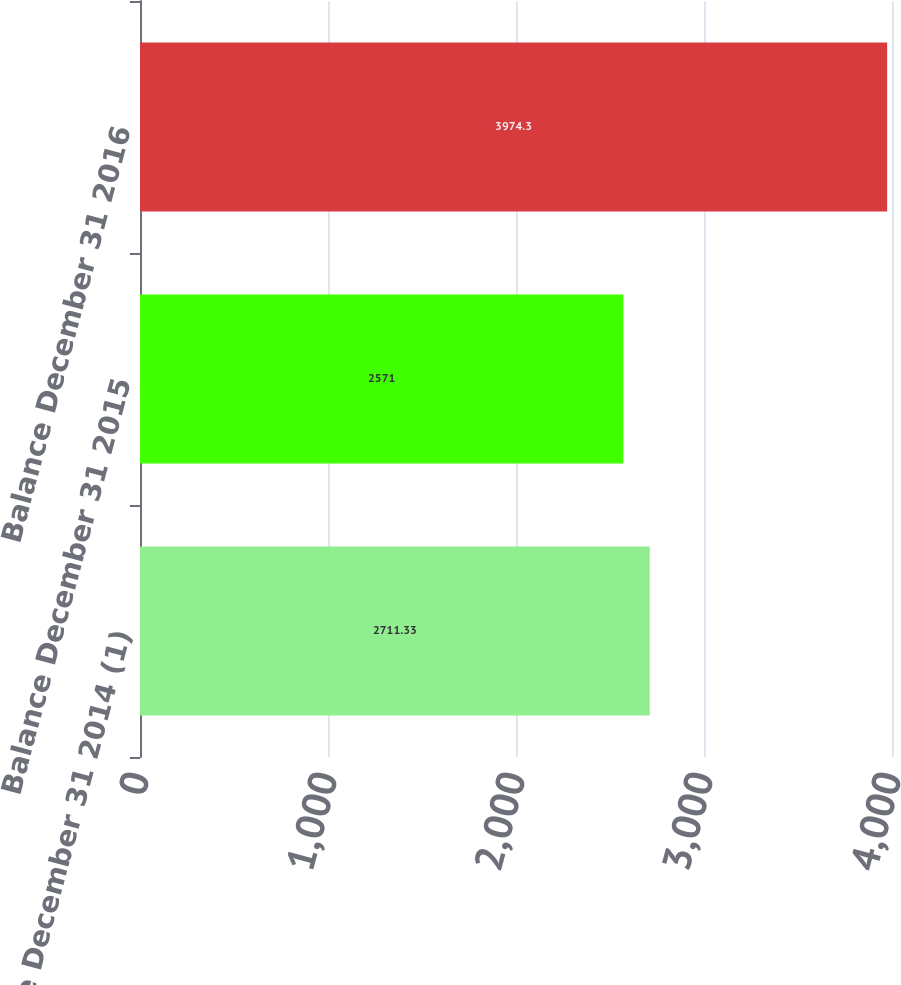<chart> <loc_0><loc_0><loc_500><loc_500><bar_chart><fcel>Balance December 31 2014 (1)<fcel>Balance December 31 2015<fcel>Balance December 31 2016<nl><fcel>2711.33<fcel>2571<fcel>3974.3<nl></chart> 